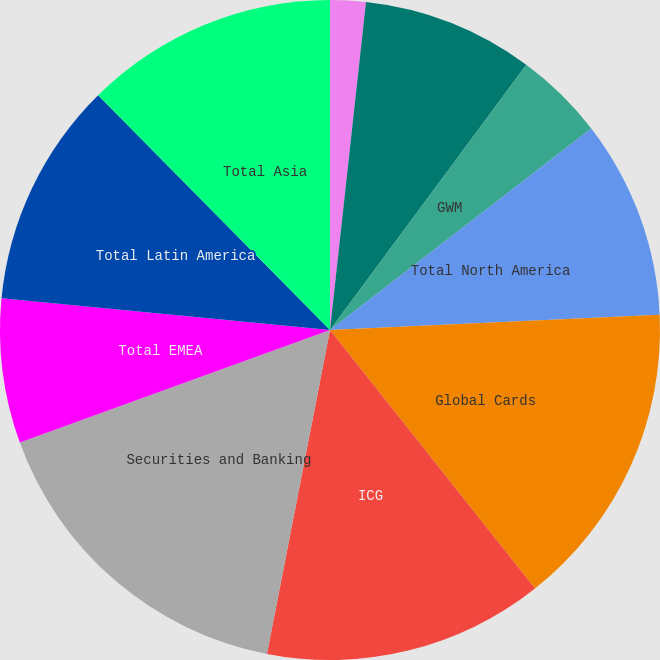Convert chart to OTSL. <chart><loc_0><loc_0><loc_500><loc_500><pie_chart><fcel>Consumer Banking<fcel>Transaction Services<fcel>GWM<fcel>Total North America<fcel>Global Cards<fcel>ICG<fcel>Securities and Banking<fcel>Total EMEA<fcel>Total Latin America<fcel>Total Asia<nl><fcel>1.74%<fcel>8.4%<fcel>4.4%<fcel>9.73%<fcel>15.06%<fcel>13.73%<fcel>16.4%<fcel>7.07%<fcel>11.07%<fcel>12.4%<nl></chart> 